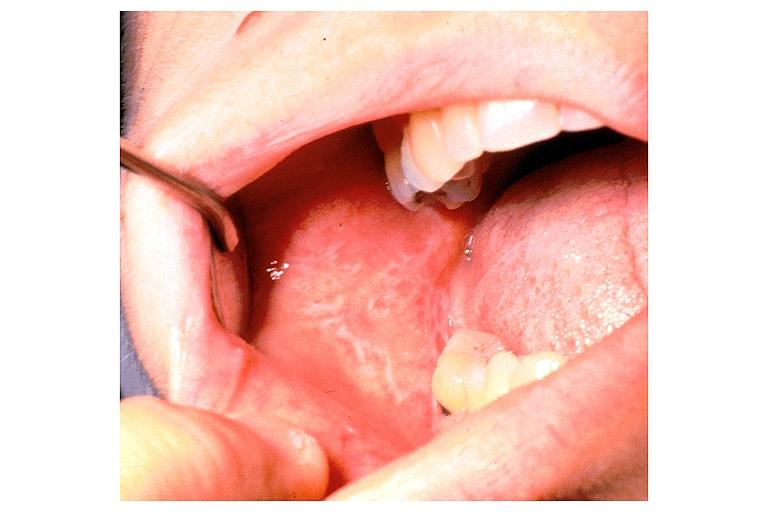what is present?
Answer the question using a single word or phrase. Oral 